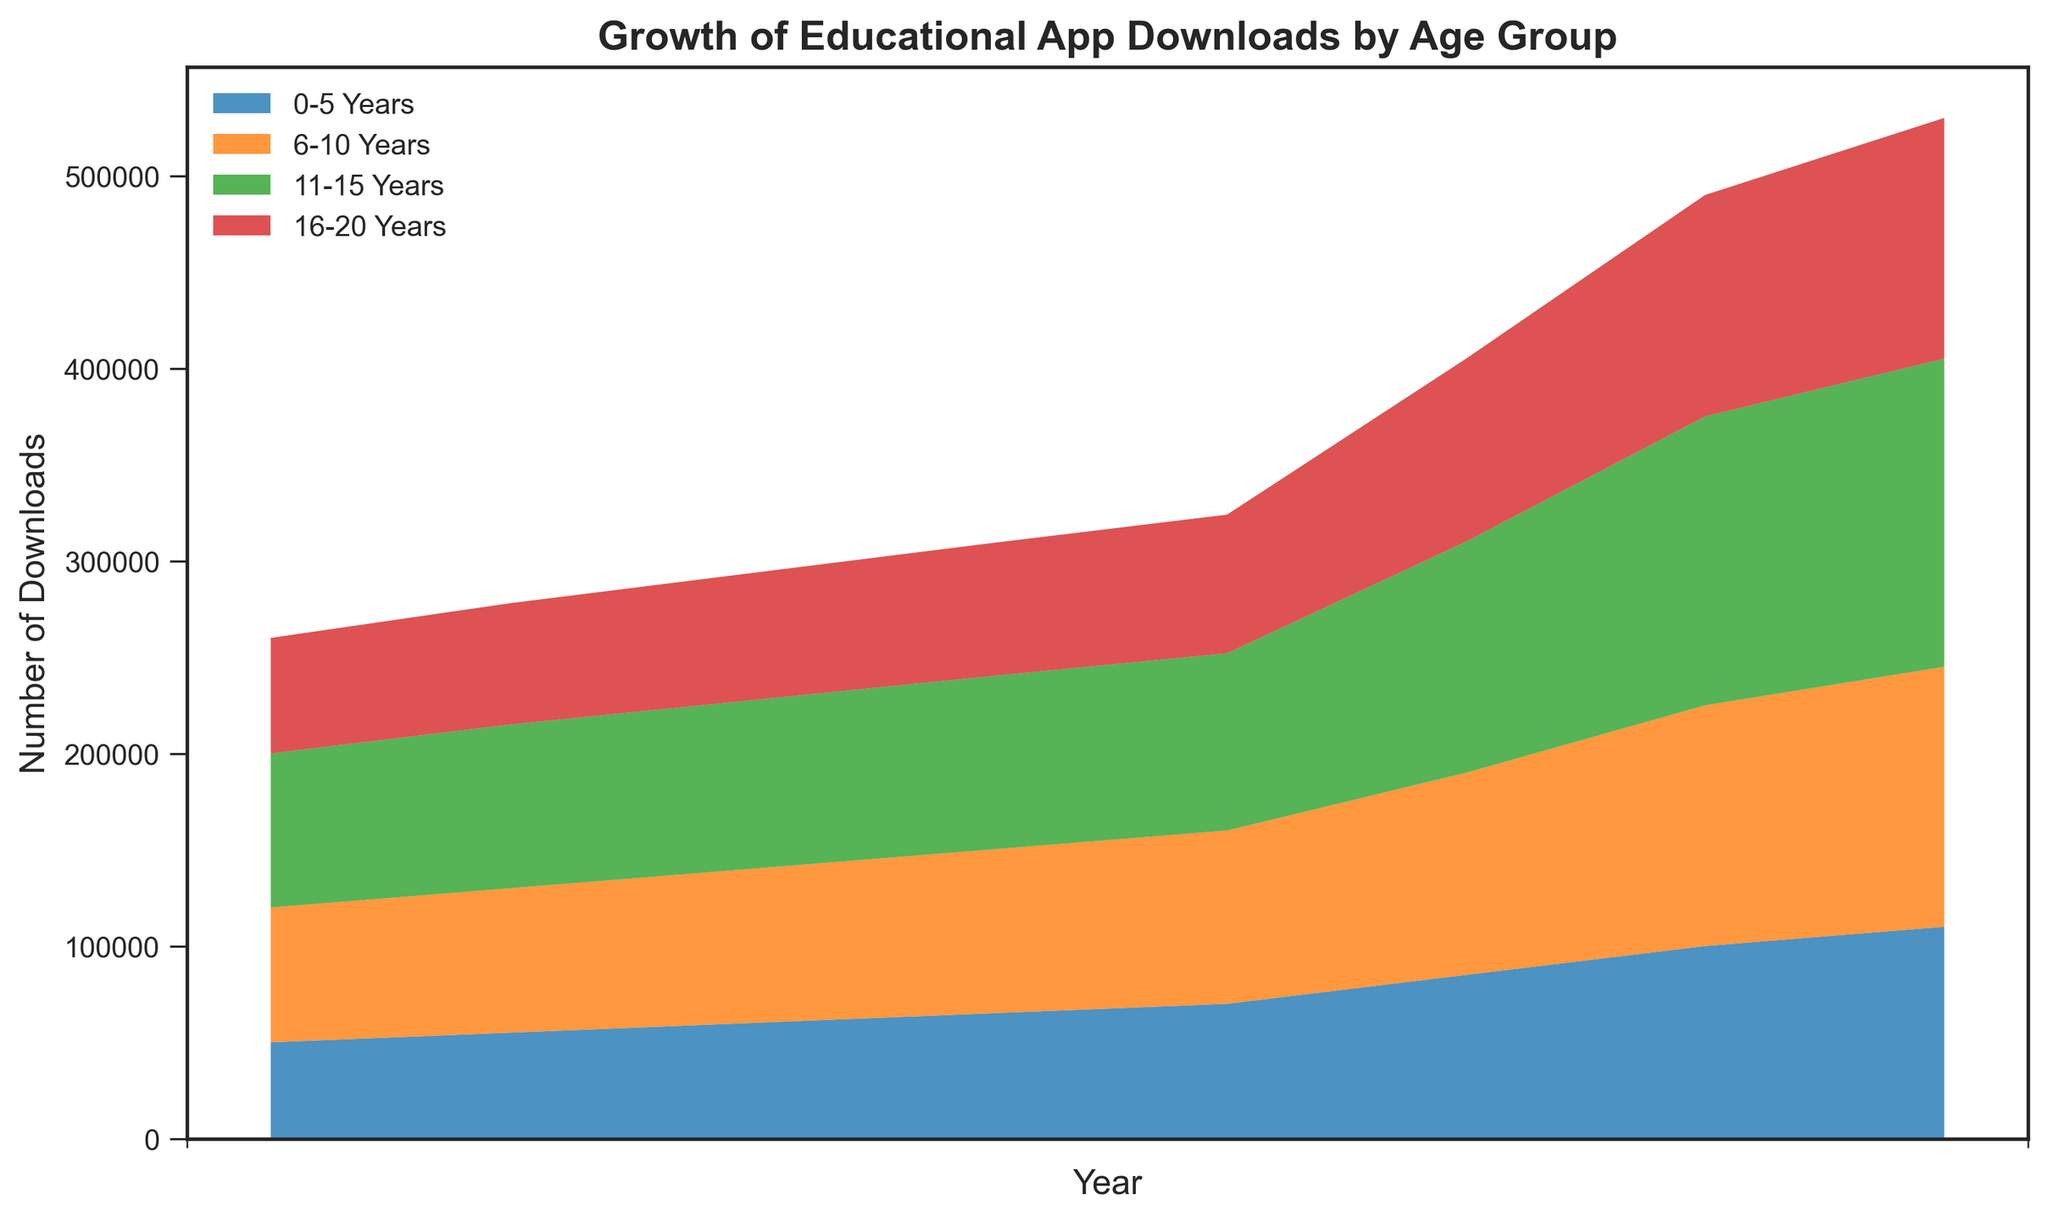Which age group had the highest number of downloads in 2022? The highest area on the chart for 2022 belongs to the '11-15 Years' age group.
Answer: 11-15 Years How did the downloads for the '16-20 Years' age group change from 2015 to 2022? Start with the download number for '16-20 Years' in 2015, which is 60,000. In 2022, it's 125,000. The difference is 125,000 - 60,000 = 65,000. Thus, the downloads increased by 65,000.
Answer: Increased by 65,000 In which year did the '0-5 Years' age group see the largest increase in downloads compared to the previous year? Examine the year-over-year changes: from 2019 to 2020, the downloads went from 70,000 to 85,000, an increase of 15,000. This is the largest increase for the '0-5 Years' group.
Answer: 2020 Which age group had the slowest growth in downloads over the period from 2015 to 2022? Calculate the total change for each group: 
- '0-5 Years': 110,000 - 50,000 = 60,000
- '6-10 Years': 135,000 - 70,000 = 65,000
- '11-15 Years': 160,000 - 80,000 = 80,000
- '16-20 Years': 125,000 - 60,000 = 65,000
The '0-5 Years' group has the smallest increase.
Answer: 0-5 Years What is the total number of downloads across all age groups for the year 2020? Add the downloads for each age group in 2020:
85,000 (0-5) + 105,000 (6-10) + 120,000 (11-15) + 95,000 (16-20) = 405,000.
Answer: 405,000 Between which years did the '11-15 Years' age group see the greatest increase in downloads? The maximum increase occurred between 2020 and 2021, with an increase from 120,000 to 150,000, a difference of 30,000.
Answer: 2020-2021 Which age group saw the smallest increase in downloads between 2020 and 2021? Compare increases: 
- '0-5 Years': 100,000 - 85,000 = 15,000
- '6-10 Years': 125,000 - 105,000 = 20,000
- '11-15 Years': 150,000 - 120,000 = 30,000
- '16-20 Years': 115,000 - 95,000 = 20,000
The '0-5 Years' group has the smallest increase.
Answer: 0-5 Years 